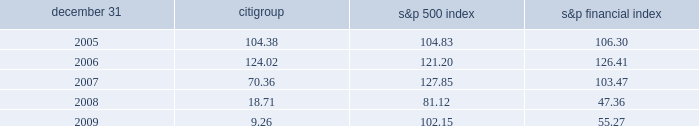Comparison of five-year cumulative total return the following graph compares the cumulative total return on citigroup 2019s common stock with the s&p 500 index and the s&p financial index over the five-year period extending through december 31 , 2009 .
The graph assumes that $ 100 was invested on december 31 , 2004 in citigroup 2019s common stock , the s&p 500 index and the s&p financial index and that all dividends were reinvested .
Citigroup s&p 500 index s&p financial index 2005 2006 2007 2008 2009 comparison of five-year cumulative total return for the years ended .

What was the percent of the decline on the citigroup cumulative total return from 2007 to 2008? 
Computations: ((18.71 - 70.36) / 70.36)
Answer: -0.73408. 